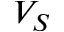Convert formula to latex. <formula><loc_0><loc_0><loc_500><loc_500>V _ { S }</formula> 